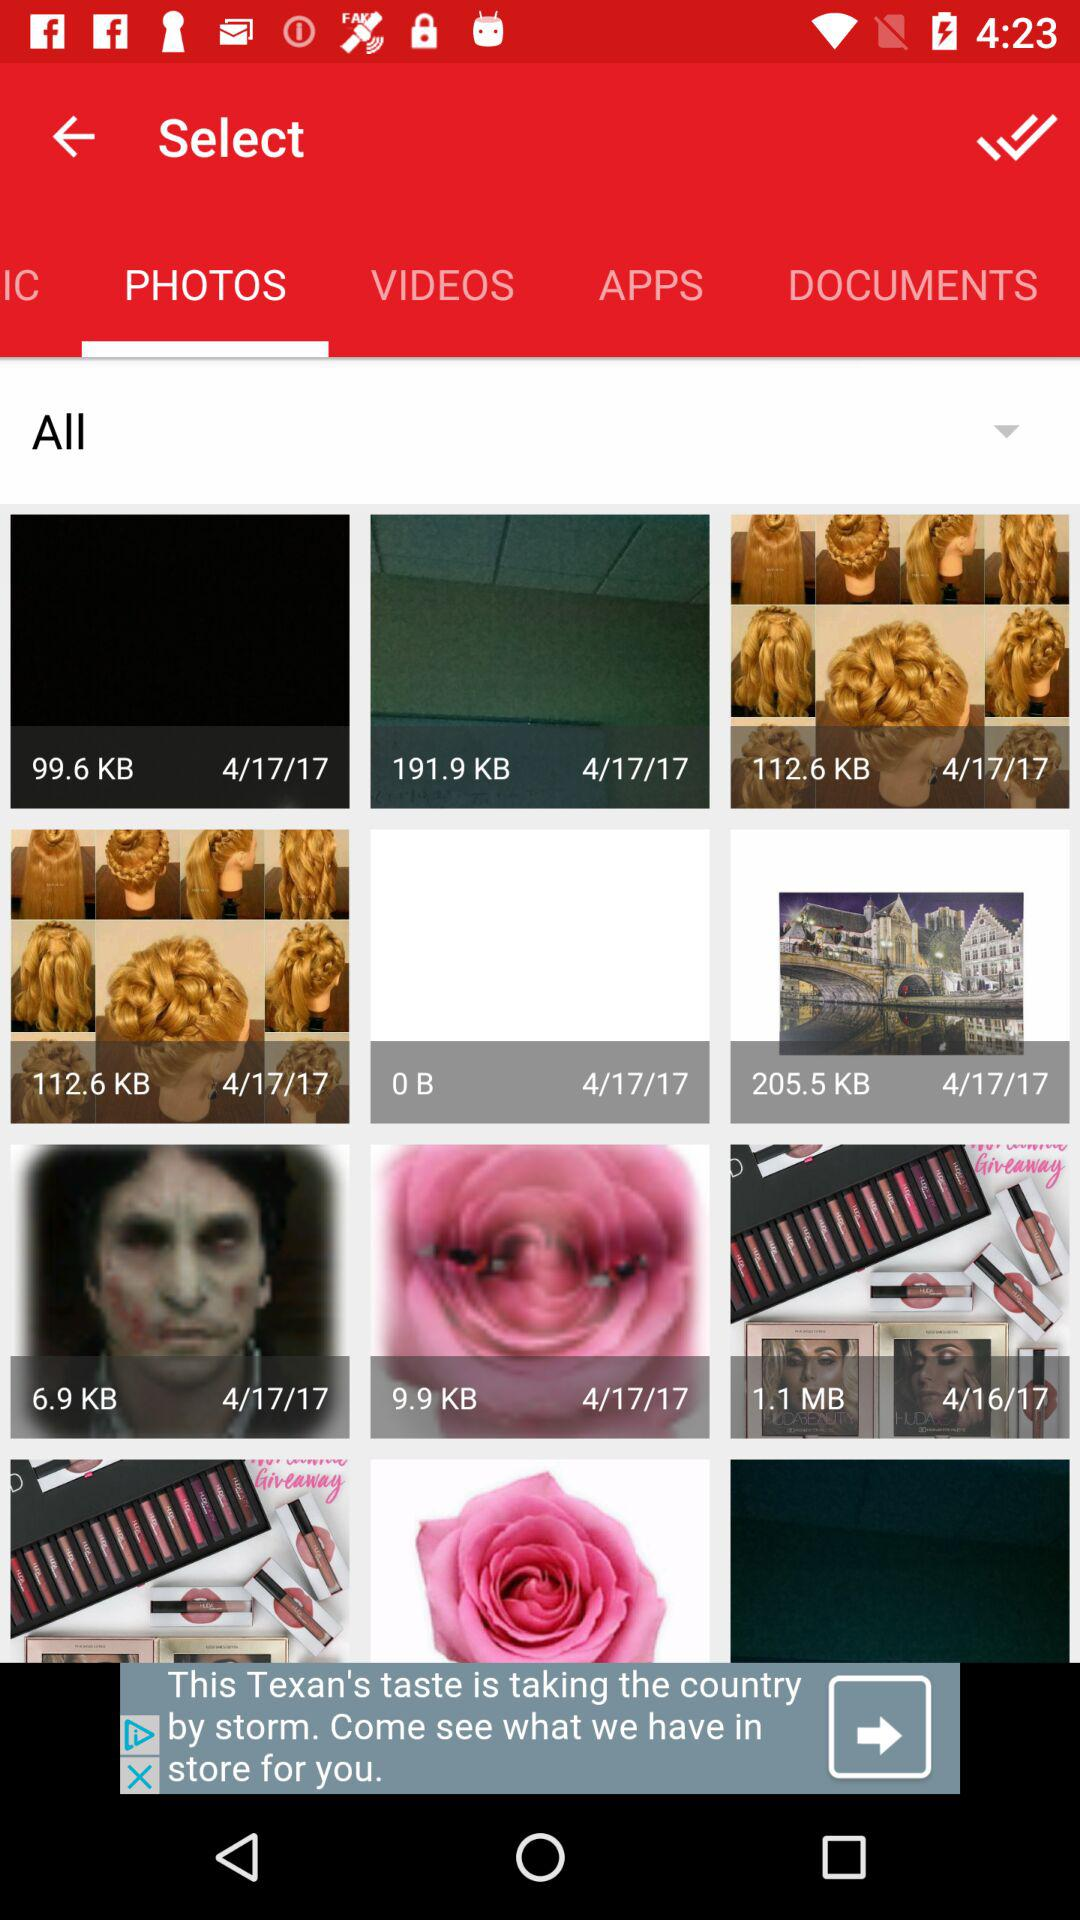Which tab is open? The open tab is "PHOTOS". 